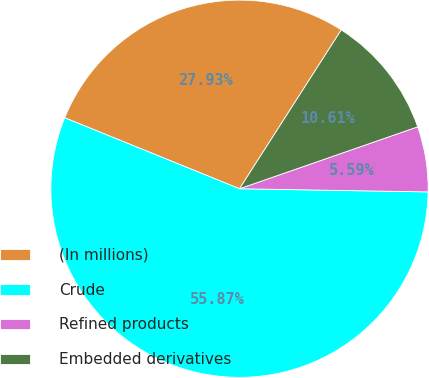Convert chart. <chart><loc_0><loc_0><loc_500><loc_500><pie_chart><fcel>(In millions)<fcel>Crude<fcel>Refined products<fcel>Embedded derivatives<nl><fcel>27.93%<fcel>55.87%<fcel>5.59%<fcel>10.61%<nl></chart> 